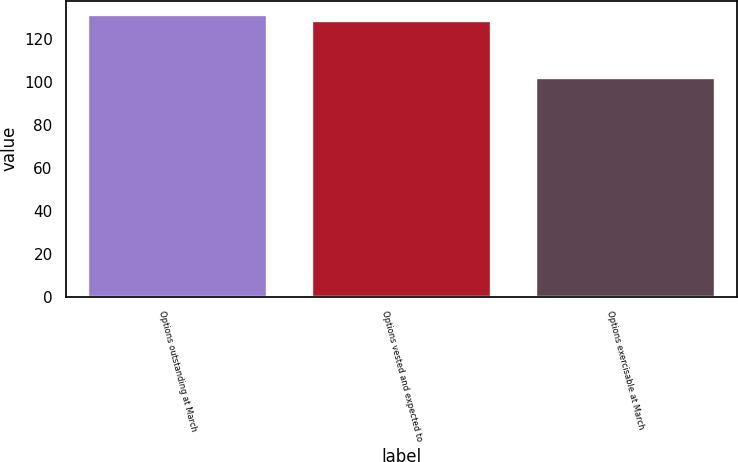Convert chart. <chart><loc_0><loc_0><loc_500><loc_500><bar_chart><fcel>Options outstanding at March<fcel>Options vested and expected to<fcel>Options exercisable at March<nl><fcel>131.31<fcel>128.57<fcel>101.89<nl></chart> 